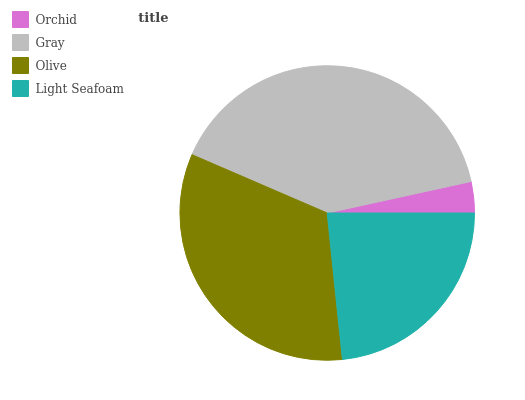Is Orchid the minimum?
Answer yes or no. Yes. Is Gray the maximum?
Answer yes or no. Yes. Is Olive the minimum?
Answer yes or no. No. Is Olive the maximum?
Answer yes or no. No. Is Gray greater than Olive?
Answer yes or no. Yes. Is Olive less than Gray?
Answer yes or no. Yes. Is Olive greater than Gray?
Answer yes or no. No. Is Gray less than Olive?
Answer yes or no. No. Is Olive the high median?
Answer yes or no. Yes. Is Light Seafoam the low median?
Answer yes or no. Yes. Is Gray the high median?
Answer yes or no. No. Is Orchid the low median?
Answer yes or no. No. 